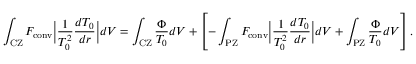<formula> <loc_0><loc_0><loc_500><loc_500>\int _ { C Z } F _ { c o n v } \left | \frac { 1 } { T _ { 0 } ^ { 2 } } \frac { d T _ { 0 } } { d r } \right | d V = \int _ { C Z } \frac { \Phi } { T _ { 0 } } d V + \left [ - \int _ { P Z } F _ { c o n v } \left | \frac { 1 } { T _ { 0 } ^ { 2 } } \frac { d T _ { 0 } } { d r } \right | d V + \int _ { P Z } \frac { \Phi } { T _ { 0 } } d V \right ] .</formula> 